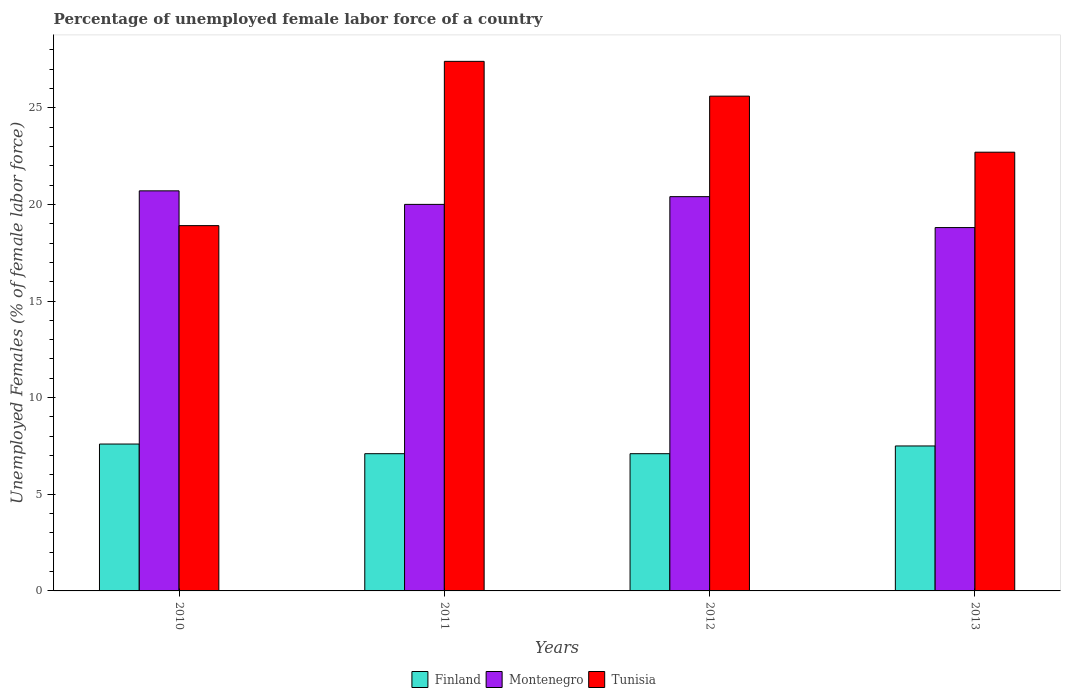How many groups of bars are there?
Offer a terse response. 4. Are the number of bars per tick equal to the number of legend labels?
Offer a terse response. Yes. What is the percentage of unemployed female labor force in Tunisia in 2013?
Your answer should be compact. 22.7. Across all years, what is the maximum percentage of unemployed female labor force in Tunisia?
Your answer should be compact. 27.4. Across all years, what is the minimum percentage of unemployed female labor force in Montenegro?
Provide a short and direct response. 18.8. In which year was the percentage of unemployed female labor force in Finland maximum?
Ensure brevity in your answer.  2010. What is the total percentage of unemployed female labor force in Tunisia in the graph?
Your answer should be compact. 94.6. What is the difference between the percentage of unemployed female labor force in Tunisia in 2012 and that in 2013?
Ensure brevity in your answer.  2.9. What is the difference between the percentage of unemployed female labor force in Tunisia in 2011 and the percentage of unemployed female labor force in Montenegro in 2010?
Your answer should be very brief. 6.7. What is the average percentage of unemployed female labor force in Tunisia per year?
Ensure brevity in your answer.  23.65. In the year 2011, what is the difference between the percentage of unemployed female labor force in Finland and percentage of unemployed female labor force in Tunisia?
Your answer should be very brief. -20.3. In how many years, is the percentage of unemployed female labor force in Tunisia greater than 3 %?
Your response must be concise. 4. What is the ratio of the percentage of unemployed female labor force in Montenegro in 2011 to that in 2013?
Your answer should be compact. 1.06. Is the difference between the percentage of unemployed female labor force in Finland in 2010 and 2011 greater than the difference between the percentage of unemployed female labor force in Tunisia in 2010 and 2011?
Make the answer very short. Yes. What is the difference between the highest and the second highest percentage of unemployed female labor force in Montenegro?
Ensure brevity in your answer.  0.3. What is the difference between the highest and the lowest percentage of unemployed female labor force in Tunisia?
Give a very brief answer. 8.5. In how many years, is the percentage of unemployed female labor force in Finland greater than the average percentage of unemployed female labor force in Finland taken over all years?
Offer a terse response. 2. Is the sum of the percentage of unemployed female labor force in Finland in 2012 and 2013 greater than the maximum percentage of unemployed female labor force in Montenegro across all years?
Offer a very short reply. No. What does the 2nd bar from the left in 2013 represents?
Keep it short and to the point. Montenegro. What does the 3rd bar from the right in 2012 represents?
Your response must be concise. Finland. Is it the case that in every year, the sum of the percentage of unemployed female labor force in Finland and percentage of unemployed female labor force in Tunisia is greater than the percentage of unemployed female labor force in Montenegro?
Ensure brevity in your answer.  Yes. How many bars are there?
Give a very brief answer. 12. Are the values on the major ticks of Y-axis written in scientific E-notation?
Give a very brief answer. No. Does the graph contain grids?
Your answer should be compact. No. What is the title of the graph?
Provide a succinct answer. Percentage of unemployed female labor force of a country. What is the label or title of the X-axis?
Your answer should be very brief. Years. What is the label or title of the Y-axis?
Make the answer very short. Unemployed Females (% of female labor force). What is the Unemployed Females (% of female labor force) in Finland in 2010?
Your response must be concise. 7.6. What is the Unemployed Females (% of female labor force) in Montenegro in 2010?
Your answer should be compact. 20.7. What is the Unemployed Females (% of female labor force) of Tunisia in 2010?
Provide a succinct answer. 18.9. What is the Unemployed Females (% of female labor force) of Finland in 2011?
Ensure brevity in your answer.  7.1. What is the Unemployed Females (% of female labor force) of Montenegro in 2011?
Provide a short and direct response. 20. What is the Unemployed Females (% of female labor force) of Tunisia in 2011?
Offer a terse response. 27.4. What is the Unemployed Females (% of female labor force) of Finland in 2012?
Your answer should be very brief. 7.1. What is the Unemployed Females (% of female labor force) in Montenegro in 2012?
Make the answer very short. 20.4. What is the Unemployed Females (% of female labor force) in Tunisia in 2012?
Make the answer very short. 25.6. What is the Unemployed Females (% of female labor force) in Montenegro in 2013?
Give a very brief answer. 18.8. What is the Unemployed Females (% of female labor force) of Tunisia in 2013?
Keep it short and to the point. 22.7. Across all years, what is the maximum Unemployed Females (% of female labor force) of Finland?
Offer a very short reply. 7.6. Across all years, what is the maximum Unemployed Females (% of female labor force) in Montenegro?
Your response must be concise. 20.7. Across all years, what is the maximum Unemployed Females (% of female labor force) of Tunisia?
Offer a very short reply. 27.4. Across all years, what is the minimum Unemployed Females (% of female labor force) in Finland?
Your answer should be very brief. 7.1. Across all years, what is the minimum Unemployed Females (% of female labor force) in Montenegro?
Keep it short and to the point. 18.8. Across all years, what is the minimum Unemployed Females (% of female labor force) of Tunisia?
Provide a succinct answer. 18.9. What is the total Unemployed Females (% of female labor force) of Finland in the graph?
Offer a terse response. 29.3. What is the total Unemployed Females (% of female labor force) in Montenegro in the graph?
Your response must be concise. 79.9. What is the total Unemployed Females (% of female labor force) of Tunisia in the graph?
Your answer should be very brief. 94.6. What is the difference between the Unemployed Females (% of female labor force) in Montenegro in 2010 and that in 2012?
Your answer should be compact. 0.3. What is the difference between the Unemployed Females (% of female labor force) in Tunisia in 2010 and that in 2012?
Provide a short and direct response. -6.7. What is the difference between the Unemployed Females (% of female labor force) in Montenegro in 2010 and that in 2013?
Offer a terse response. 1.9. What is the difference between the Unemployed Females (% of female labor force) in Tunisia in 2010 and that in 2013?
Provide a short and direct response. -3.8. What is the difference between the Unemployed Females (% of female labor force) of Finland in 2011 and that in 2012?
Your answer should be compact. 0. What is the difference between the Unemployed Females (% of female labor force) in Montenegro in 2011 and that in 2013?
Your response must be concise. 1.2. What is the difference between the Unemployed Females (% of female labor force) in Finland in 2012 and that in 2013?
Give a very brief answer. -0.4. What is the difference between the Unemployed Females (% of female labor force) in Tunisia in 2012 and that in 2013?
Offer a terse response. 2.9. What is the difference between the Unemployed Females (% of female labor force) of Finland in 2010 and the Unemployed Females (% of female labor force) of Montenegro in 2011?
Keep it short and to the point. -12.4. What is the difference between the Unemployed Females (% of female labor force) of Finland in 2010 and the Unemployed Females (% of female labor force) of Tunisia in 2011?
Give a very brief answer. -19.8. What is the difference between the Unemployed Females (% of female labor force) of Montenegro in 2010 and the Unemployed Females (% of female labor force) of Tunisia in 2011?
Your answer should be very brief. -6.7. What is the difference between the Unemployed Females (% of female labor force) of Finland in 2010 and the Unemployed Females (% of female labor force) of Tunisia in 2012?
Provide a short and direct response. -18. What is the difference between the Unemployed Females (% of female labor force) in Montenegro in 2010 and the Unemployed Females (% of female labor force) in Tunisia in 2012?
Make the answer very short. -4.9. What is the difference between the Unemployed Females (% of female labor force) of Finland in 2010 and the Unemployed Females (% of female labor force) of Montenegro in 2013?
Give a very brief answer. -11.2. What is the difference between the Unemployed Females (% of female labor force) of Finland in 2010 and the Unemployed Females (% of female labor force) of Tunisia in 2013?
Your answer should be compact. -15.1. What is the difference between the Unemployed Females (% of female labor force) of Montenegro in 2010 and the Unemployed Females (% of female labor force) of Tunisia in 2013?
Provide a short and direct response. -2. What is the difference between the Unemployed Females (% of female labor force) in Finland in 2011 and the Unemployed Females (% of female labor force) in Tunisia in 2012?
Offer a very short reply. -18.5. What is the difference between the Unemployed Females (% of female labor force) in Finland in 2011 and the Unemployed Females (% of female labor force) in Montenegro in 2013?
Make the answer very short. -11.7. What is the difference between the Unemployed Females (% of female labor force) in Finland in 2011 and the Unemployed Females (% of female labor force) in Tunisia in 2013?
Keep it short and to the point. -15.6. What is the difference between the Unemployed Females (% of female labor force) of Finland in 2012 and the Unemployed Females (% of female labor force) of Montenegro in 2013?
Your response must be concise. -11.7. What is the difference between the Unemployed Females (% of female labor force) in Finland in 2012 and the Unemployed Females (% of female labor force) in Tunisia in 2013?
Your response must be concise. -15.6. What is the difference between the Unemployed Females (% of female labor force) of Montenegro in 2012 and the Unemployed Females (% of female labor force) of Tunisia in 2013?
Provide a succinct answer. -2.3. What is the average Unemployed Females (% of female labor force) of Finland per year?
Keep it short and to the point. 7.33. What is the average Unemployed Females (% of female labor force) in Montenegro per year?
Make the answer very short. 19.98. What is the average Unemployed Females (% of female labor force) in Tunisia per year?
Ensure brevity in your answer.  23.65. In the year 2010, what is the difference between the Unemployed Females (% of female labor force) of Finland and Unemployed Females (% of female labor force) of Tunisia?
Your response must be concise. -11.3. In the year 2010, what is the difference between the Unemployed Females (% of female labor force) of Montenegro and Unemployed Females (% of female labor force) of Tunisia?
Provide a short and direct response. 1.8. In the year 2011, what is the difference between the Unemployed Females (% of female labor force) of Finland and Unemployed Females (% of female labor force) of Tunisia?
Make the answer very short. -20.3. In the year 2012, what is the difference between the Unemployed Females (% of female labor force) of Finland and Unemployed Females (% of female labor force) of Montenegro?
Make the answer very short. -13.3. In the year 2012, what is the difference between the Unemployed Females (% of female labor force) in Finland and Unemployed Females (% of female labor force) in Tunisia?
Offer a very short reply. -18.5. In the year 2013, what is the difference between the Unemployed Females (% of female labor force) in Finland and Unemployed Females (% of female labor force) in Montenegro?
Your answer should be very brief. -11.3. In the year 2013, what is the difference between the Unemployed Females (% of female labor force) of Finland and Unemployed Females (% of female labor force) of Tunisia?
Give a very brief answer. -15.2. In the year 2013, what is the difference between the Unemployed Females (% of female labor force) in Montenegro and Unemployed Females (% of female labor force) in Tunisia?
Keep it short and to the point. -3.9. What is the ratio of the Unemployed Females (% of female labor force) in Finland in 2010 to that in 2011?
Offer a terse response. 1.07. What is the ratio of the Unemployed Females (% of female labor force) of Montenegro in 2010 to that in 2011?
Your answer should be very brief. 1.03. What is the ratio of the Unemployed Females (% of female labor force) in Tunisia in 2010 to that in 2011?
Provide a short and direct response. 0.69. What is the ratio of the Unemployed Females (% of female labor force) in Finland in 2010 to that in 2012?
Offer a very short reply. 1.07. What is the ratio of the Unemployed Females (% of female labor force) in Montenegro in 2010 to that in 2012?
Your answer should be compact. 1.01. What is the ratio of the Unemployed Females (% of female labor force) of Tunisia in 2010 to that in 2012?
Provide a succinct answer. 0.74. What is the ratio of the Unemployed Females (% of female labor force) in Finland in 2010 to that in 2013?
Provide a short and direct response. 1.01. What is the ratio of the Unemployed Females (% of female labor force) in Montenegro in 2010 to that in 2013?
Offer a very short reply. 1.1. What is the ratio of the Unemployed Females (% of female labor force) of Tunisia in 2010 to that in 2013?
Your response must be concise. 0.83. What is the ratio of the Unemployed Females (% of female labor force) of Montenegro in 2011 to that in 2012?
Ensure brevity in your answer.  0.98. What is the ratio of the Unemployed Females (% of female labor force) of Tunisia in 2011 to that in 2012?
Provide a short and direct response. 1.07. What is the ratio of the Unemployed Females (% of female labor force) in Finland in 2011 to that in 2013?
Offer a very short reply. 0.95. What is the ratio of the Unemployed Females (% of female labor force) of Montenegro in 2011 to that in 2013?
Provide a short and direct response. 1.06. What is the ratio of the Unemployed Females (% of female labor force) in Tunisia in 2011 to that in 2013?
Make the answer very short. 1.21. What is the ratio of the Unemployed Females (% of female labor force) in Finland in 2012 to that in 2013?
Ensure brevity in your answer.  0.95. What is the ratio of the Unemployed Females (% of female labor force) of Montenegro in 2012 to that in 2013?
Offer a terse response. 1.09. What is the ratio of the Unemployed Females (% of female labor force) in Tunisia in 2012 to that in 2013?
Ensure brevity in your answer.  1.13. What is the difference between the highest and the second highest Unemployed Females (% of female labor force) of Finland?
Provide a short and direct response. 0.1. What is the difference between the highest and the second highest Unemployed Females (% of female labor force) of Tunisia?
Offer a terse response. 1.8. What is the difference between the highest and the lowest Unemployed Females (% of female labor force) of Finland?
Offer a very short reply. 0.5. What is the difference between the highest and the lowest Unemployed Females (% of female labor force) of Montenegro?
Ensure brevity in your answer.  1.9. What is the difference between the highest and the lowest Unemployed Females (% of female labor force) in Tunisia?
Make the answer very short. 8.5. 